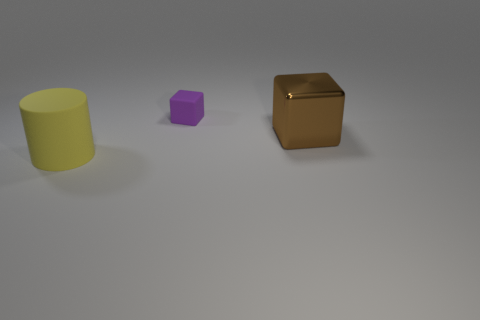Add 1 tiny green rubber things. How many objects exist? 4 Subtract all blue cubes. How many green cylinders are left? 0 Subtract all brown blocks. How many blocks are left? 1 Subtract all blocks. How many objects are left? 1 Subtract 1 blocks. How many blocks are left? 1 Subtract all brown cylinders. Subtract all red cubes. How many cylinders are left? 1 Subtract all matte objects. Subtract all large cylinders. How many objects are left? 0 Add 1 brown shiny things. How many brown shiny things are left? 2 Add 3 large spheres. How many large spheres exist? 3 Subtract 0 blue blocks. How many objects are left? 3 